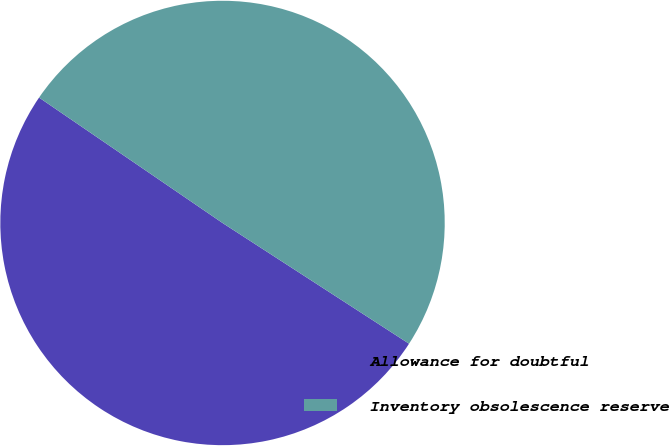Convert chart to OTSL. <chart><loc_0><loc_0><loc_500><loc_500><pie_chart><fcel>Allowance for doubtful<fcel>Inventory obsolescence reserve<nl><fcel>50.4%<fcel>49.6%<nl></chart> 